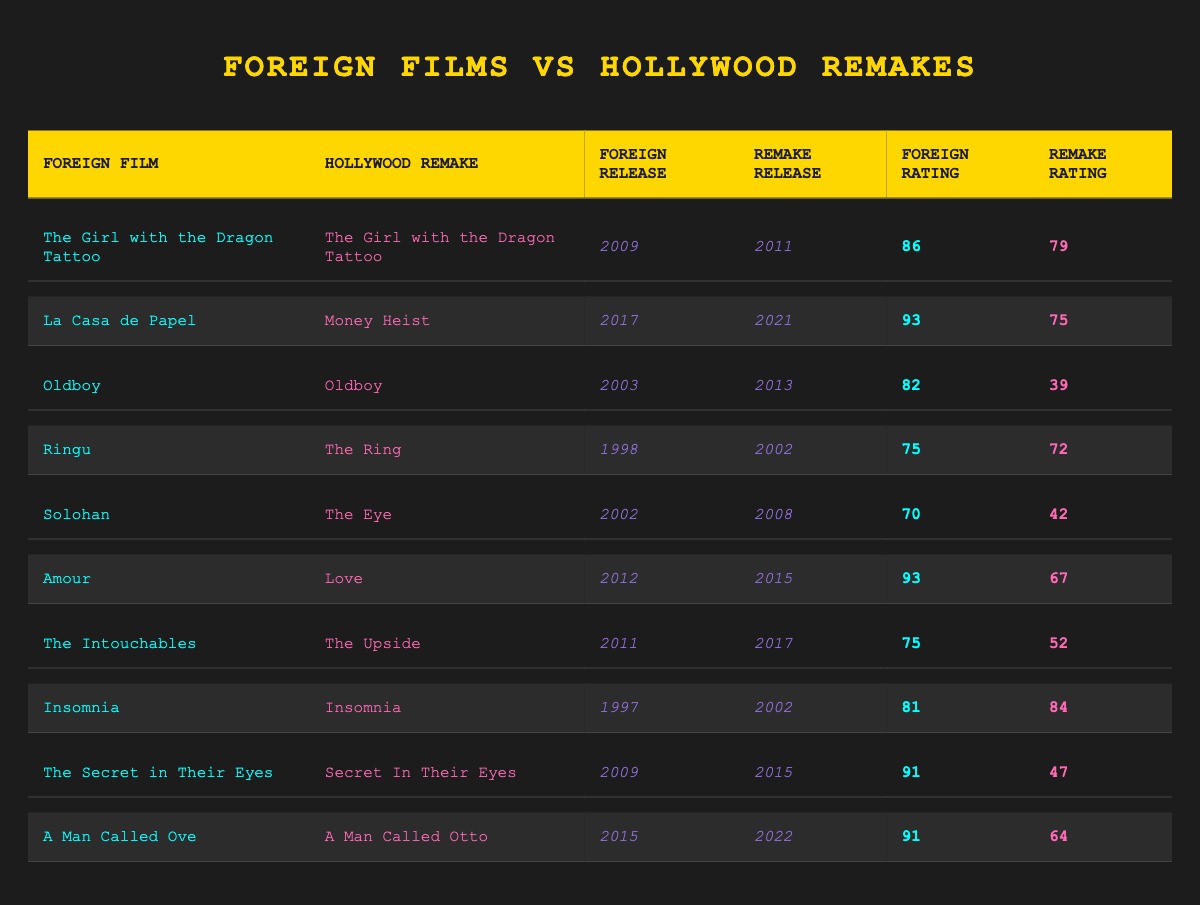What is the highest foreign rating among the films listed? The highest foreign rating comes from “La Casa de Papel” with a rating of 93.
Answer: 93 Which Hollywood remake received a higher rating than its foreign counterpart? “Insomnia” received a remake rating of 84, which is higher than the foreign film rating of 81.
Answer: Yes What is the average foreign rating of the films listed? To find the average, sum the foreign ratings (86 + 93 + 82 + 75 + 70 + 93 + 75 + 81 + 91 + 91) =  910 and divide by the number of films (10), giving an average of 91.
Answer: 91 Which film has the largest difference in ratings between the foreign film and its Hollywood remake? “Oldboy” has a difference of 43 points (82 - 39 = 43).
Answer: Oldboy Are there any films where both the foreign and remake versions had ratings below 70? Yes, "The Eye" had a foreign rating of 70 and a remake rating of 42, both below 70.
Answer: Yes Based on the table, how many remakes received ratings below 50? The remakes for “Oldboy,” “The Secret in Their Eyes,” and “The Intouchables” all received ratings below 50. There are three such remakes.
Answer: 3 What percentage of the films listed had foreign ratings above 80? Four films have foreign ratings above 80 (The Girl with the Dragon Tattoo, La Casa de Papel, Oldboy, and Amour), so (4/10)*100 = 40%.
Answer: 40% List the foreign films that had higher ratings than their remakes. "The Girl with the Dragon Tattoo", "La Casa de Papel", "Oldboy", "Ringu", "Solohan", "Amour", "The Intouchables", and "The Secret in Their Eyes" all had higher ratings than their remakes.
Answer: 8 What was the rating for “Ringu” compared to its Hollywood remake? “Ringu” had a foreign rating of 75 and its remake, “The Ring”, had a rating of 72, making the foreign version higher.
Answer: Ringu: 75, The Ring: 72 How many years apart were the release years for “A Man Called Ove” and its remake “A Man Called Otto”? The foreign film was released in 2015, and the remake in 2022, leading to a difference of 7 years.
Answer: 7 years 